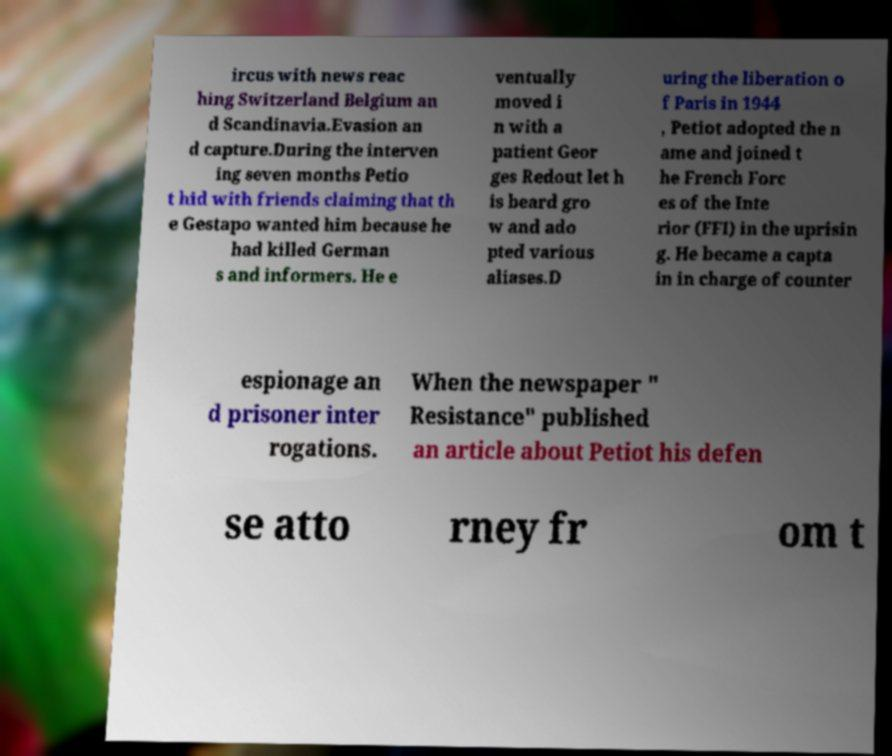For documentation purposes, I need the text within this image transcribed. Could you provide that? ircus with news reac hing Switzerland Belgium an d Scandinavia.Evasion an d capture.During the interven ing seven months Petio t hid with friends claiming that th e Gestapo wanted him because he had killed German s and informers. He e ventually moved i n with a patient Geor ges Redout let h is beard gro w and ado pted various aliases.D uring the liberation o f Paris in 1944 , Petiot adopted the n ame and joined t he French Forc es of the Inte rior (FFI) in the uprisin g. He became a capta in in charge of counter espionage an d prisoner inter rogations. When the newspaper " Resistance" published an article about Petiot his defen se atto rney fr om t 